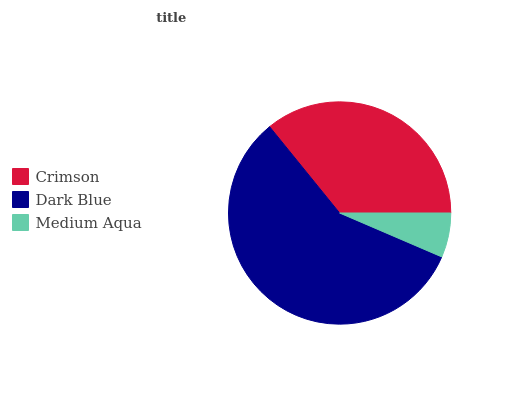Is Medium Aqua the minimum?
Answer yes or no. Yes. Is Dark Blue the maximum?
Answer yes or no. Yes. Is Dark Blue the minimum?
Answer yes or no. No. Is Medium Aqua the maximum?
Answer yes or no. No. Is Dark Blue greater than Medium Aqua?
Answer yes or no. Yes. Is Medium Aqua less than Dark Blue?
Answer yes or no. Yes. Is Medium Aqua greater than Dark Blue?
Answer yes or no. No. Is Dark Blue less than Medium Aqua?
Answer yes or no. No. Is Crimson the high median?
Answer yes or no. Yes. Is Crimson the low median?
Answer yes or no. Yes. Is Medium Aqua the high median?
Answer yes or no. No. Is Dark Blue the low median?
Answer yes or no. No. 